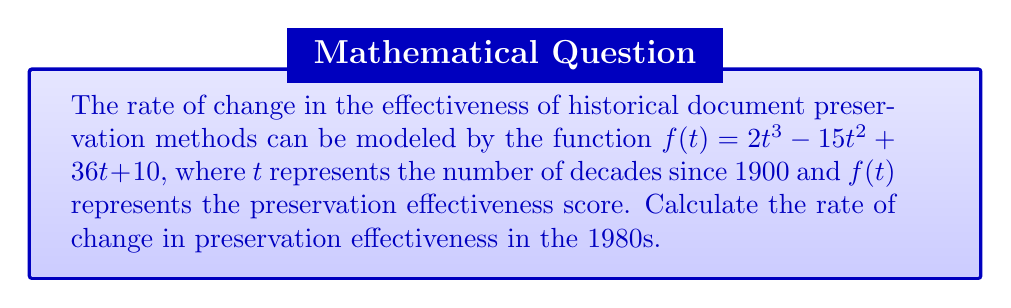Can you solve this math problem? To solve this problem, we need to follow these steps:

1. Identify the decade we're interested in:
   1980s corresponds to $t = 8$ (8 decades since 1900)

2. Find the derivative of the given function:
   $f(t) = 2t^3 - 15t^2 + 36t + 10$
   $f'(t) = 6t^2 - 30t + 36$

3. Evaluate the derivative at $t = 8$:
   $f'(8) = 6(8)^2 - 30(8) + 36$
   $f'(8) = 6(64) - 240 + 36$
   $f'(8) = 384 - 240 + 36$
   $f'(8) = 180$

The rate of change is 180 units per decade in the 1980s. As a historian, it's crucial to note that this mathematical model provides a quantitative measure of preservation effectiveness, which should be corroborated with documented historical evidence for a comprehensive understanding of preservation methods' evolution.
Answer: 180 units per decade 